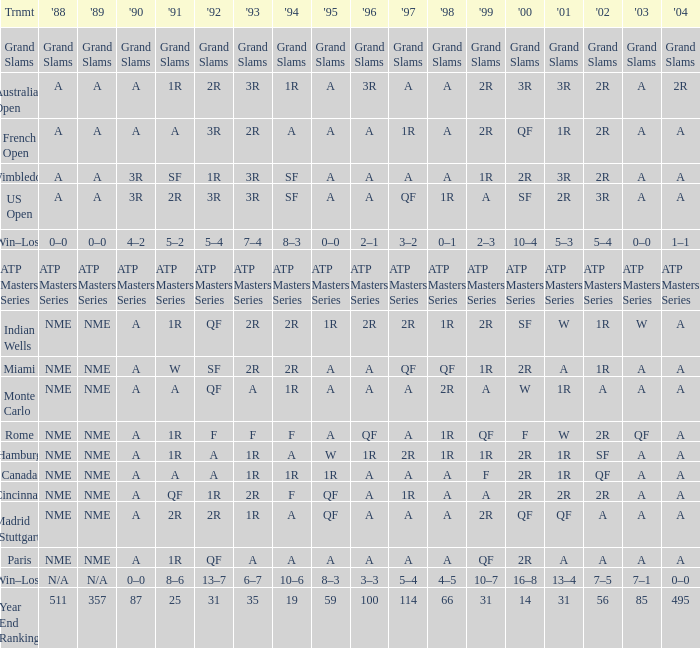What shows for 1988 when 1994 shows 10–6? N/A. 